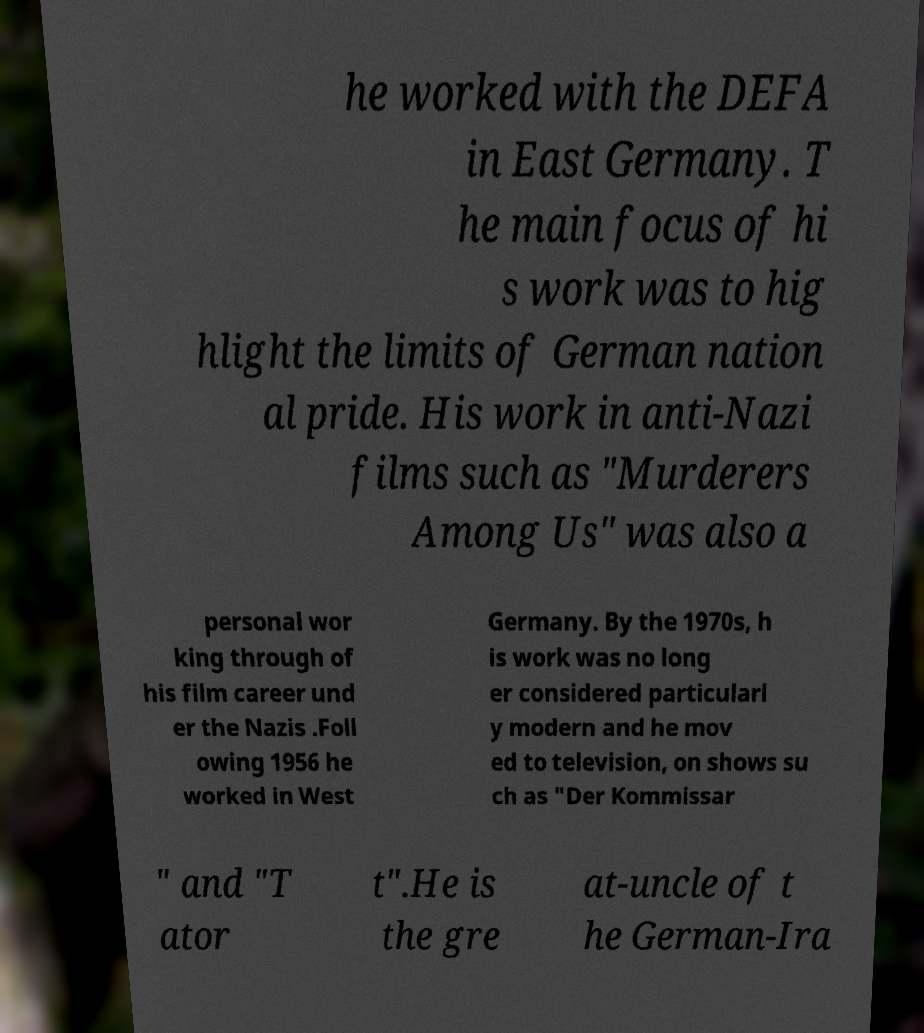I need the written content from this picture converted into text. Can you do that? he worked with the DEFA in East Germany. T he main focus of hi s work was to hig hlight the limits of German nation al pride. His work in anti-Nazi films such as "Murderers Among Us" was also a personal wor king through of his film career und er the Nazis .Foll owing 1956 he worked in West Germany. By the 1970s, h is work was no long er considered particularl y modern and he mov ed to television, on shows su ch as "Der Kommissar " and "T ator t".He is the gre at-uncle of t he German-Ira 